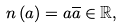<formula> <loc_0><loc_0><loc_500><loc_500>n \left ( a \right ) = a \overline { a } \in \mathbb { R } ,</formula> 